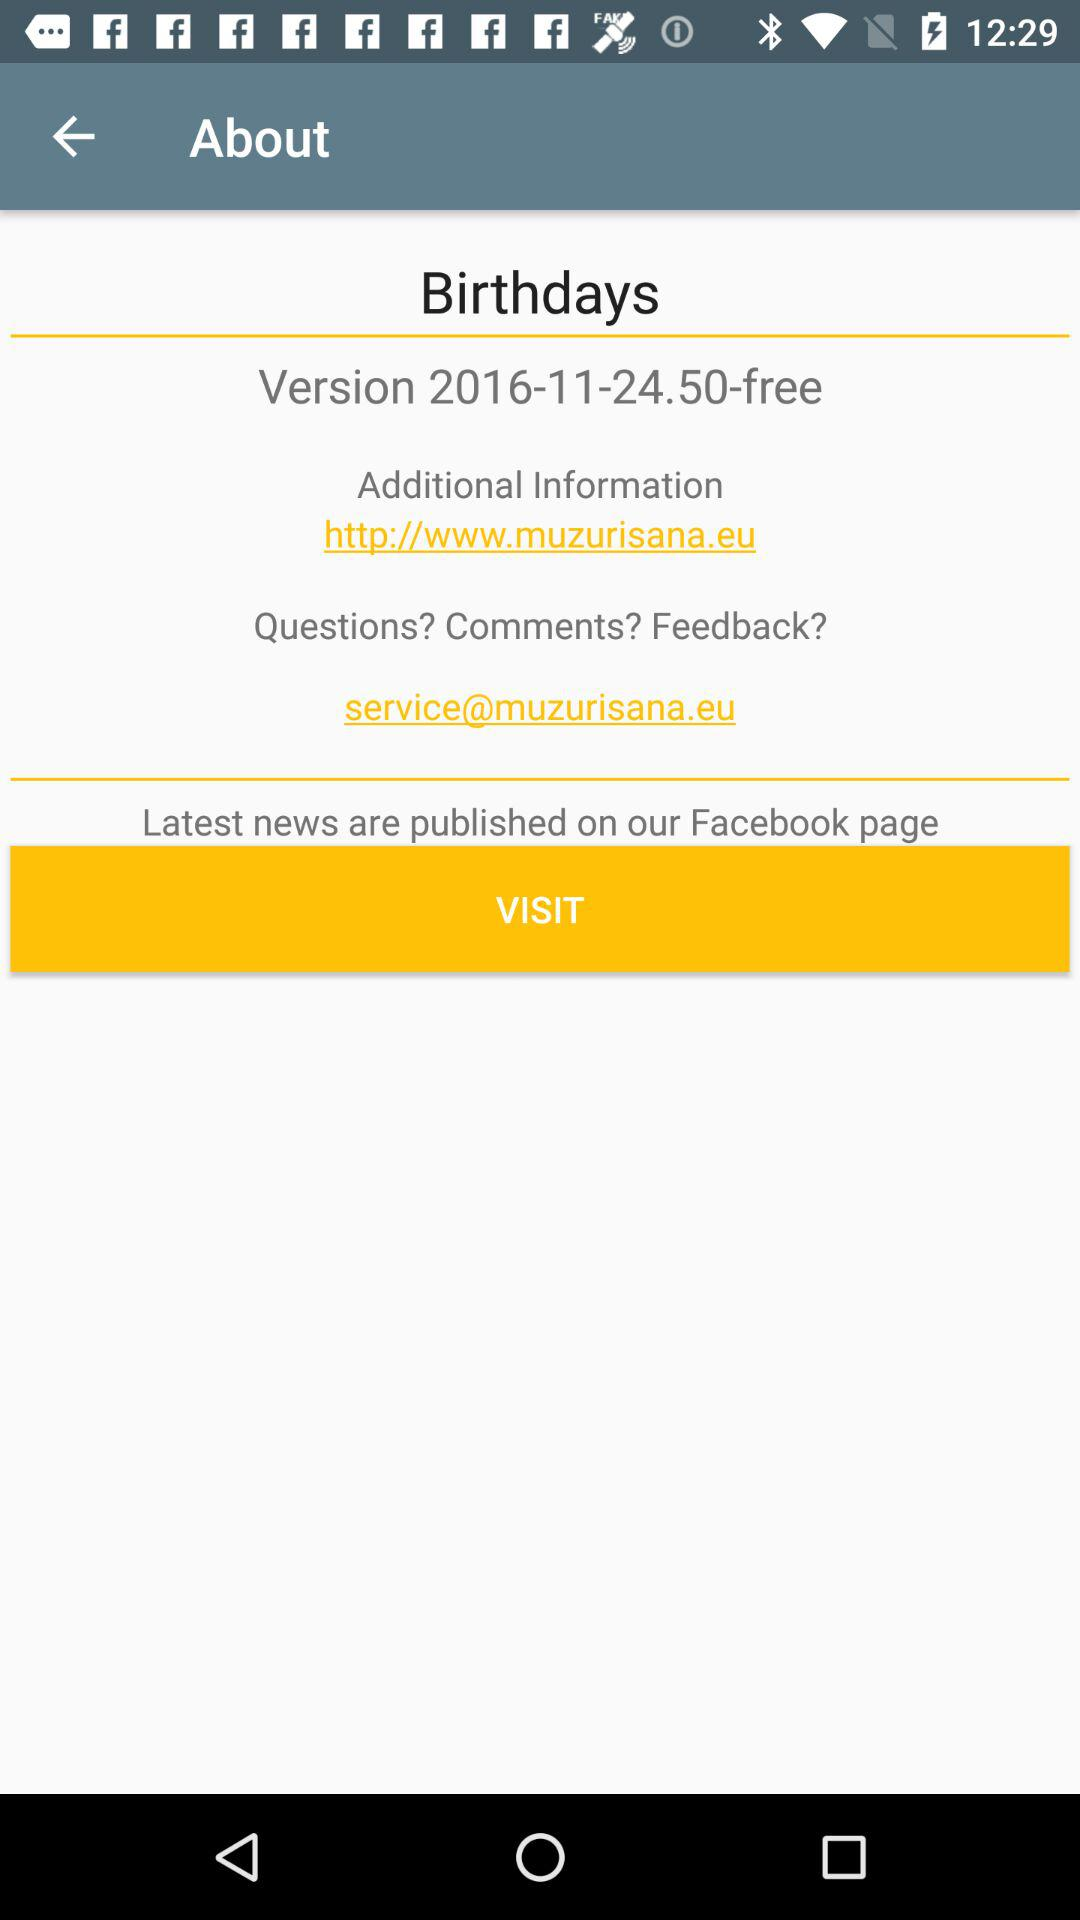What is the mail address for additional information? The mail address is service@muzurisana.eu. 